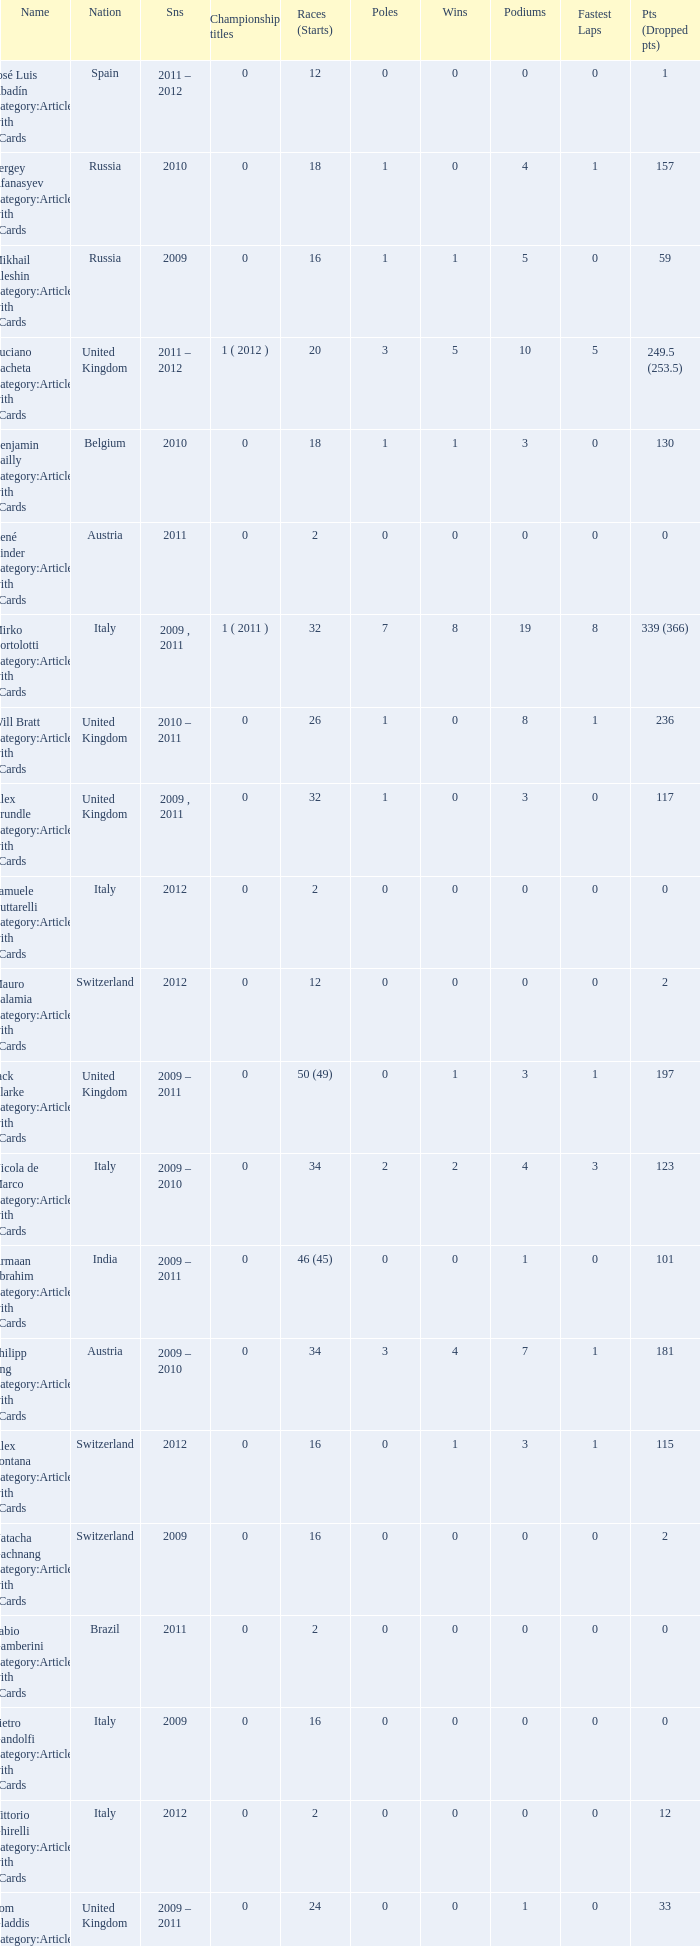What was the smallest quantity of triumphs? 0.0. 